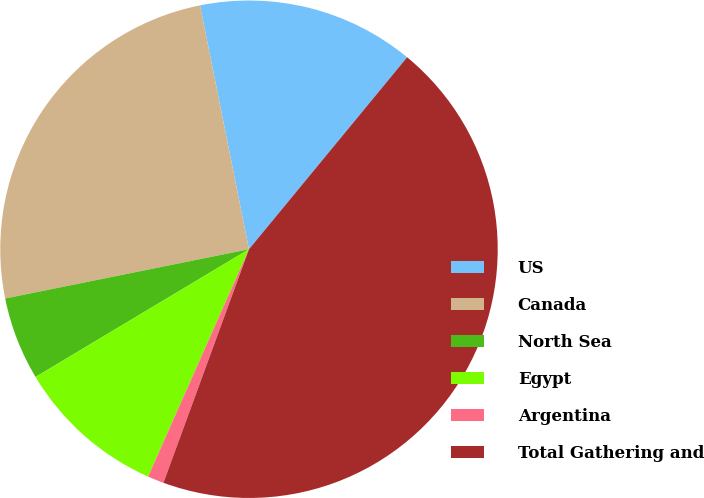<chart> <loc_0><loc_0><loc_500><loc_500><pie_chart><fcel>US<fcel>Canada<fcel>North Sea<fcel>Egypt<fcel>Argentina<fcel>Total Gathering and<nl><fcel>14.12%<fcel>25.02%<fcel>5.41%<fcel>9.77%<fcel>1.06%<fcel>44.62%<nl></chart> 